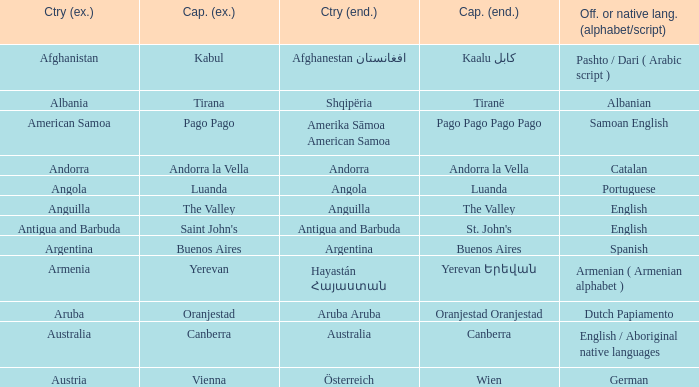What official or native languages are spoken in the country whose capital city is Canberra? English / Aboriginal native languages. 